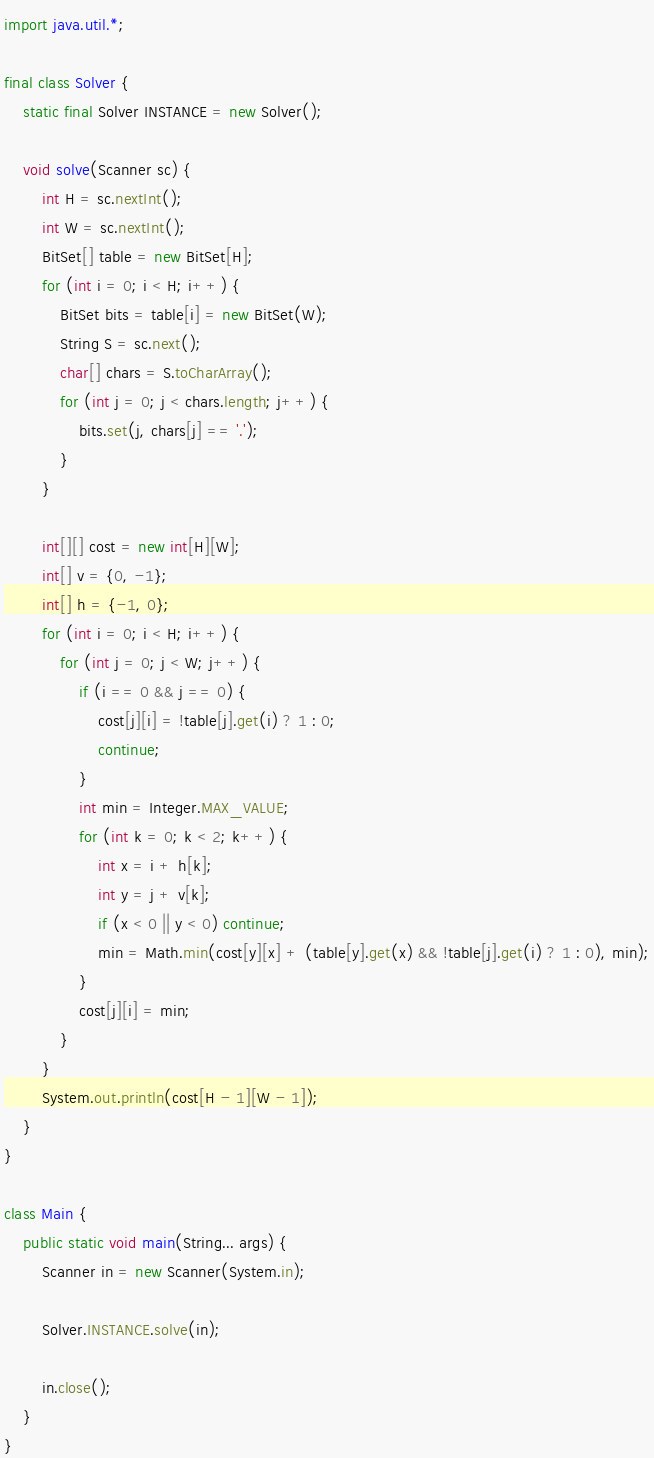<code> <loc_0><loc_0><loc_500><loc_500><_Java_>import java.util.*;

final class Solver {
	static final Solver INSTANCE = new Solver();

	void solve(Scanner sc) {
		int H = sc.nextInt();
		int W = sc.nextInt();
		BitSet[] table = new BitSet[H];
		for (int i = 0; i < H; i++) {
			BitSet bits = table[i] = new BitSet(W);
			String S = sc.next();
			char[] chars = S.toCharArray();
			for (int j = 0; j < chars.length; j++) {
				bits.set(j, chars[j] == '.');
			}
		}

		int[][] cost = new int[H][W];
		int[] v = {0, -1};
		int[] h = {-1, 0};
		for (int i = 0; i < H; i++) {
			for (int j = 0; j < W; j++) {
				if (i == 0 && j == 0) {
					cost[j][i] = !table[j].get(i) ? 1 : 0;
					continue;
				}
				int min = Integer.MAX_VALUE;
				for (int k = 0; k < 2; k++) {
					int x = i + h[k];
					int y = j + v[k];
					if (x < 0 || y < 0) continue;
					min = Math.min(cost[y][x] + (table[y].get(x) && !table[j].get(i) ? 1 : 0), min);
				}
				cost[j][i] = min;
			}
		}
		System.out.println(cost[H - 1][W - 1]);
	}
}

class Main {
	public static void main(String... args) {
		Scanner in = new Scanner(System.in);

		Solver.INSTANCE.solve(in);

		in.close();
	}
}</code> 